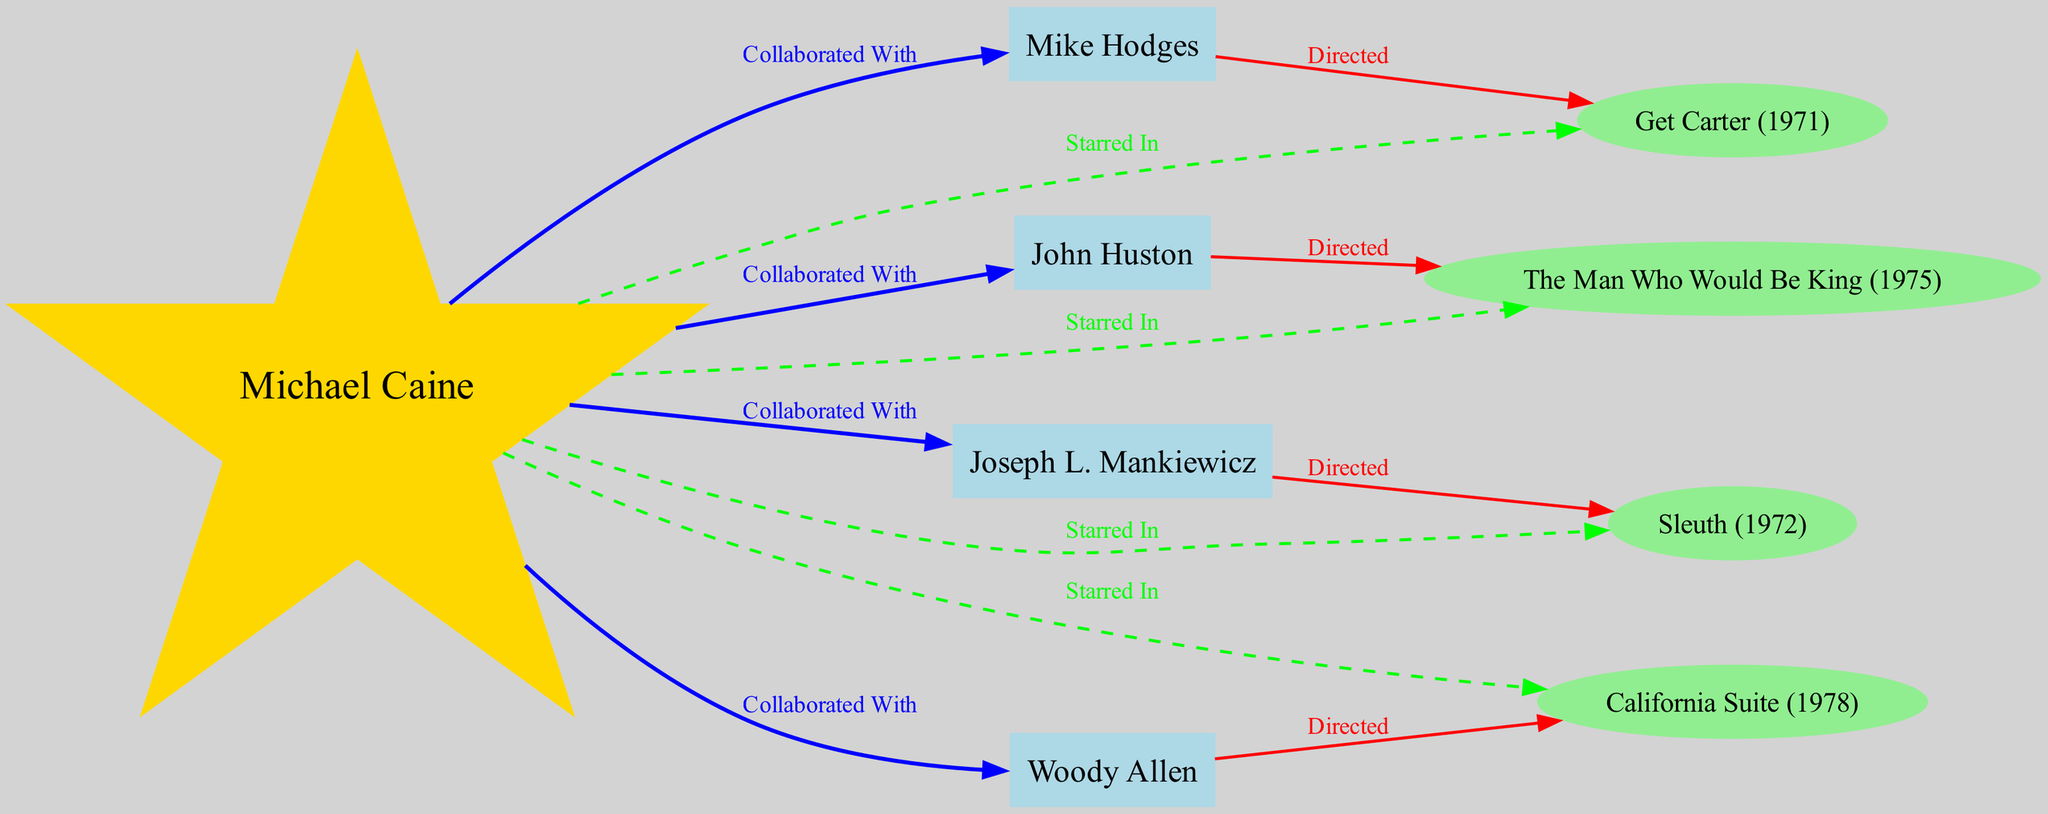What actor is at the center of the diagram? The diagram features Michael Caine as the central figure, represented as a star node. All connections and collaborations revolve around him, indicating his central role in the network of directors and films.
Answer: Michael Caine How many directors collaborated with Michael Caine? There are four directors listed as having collaborated with Michael Caine: John Huston, Mike Hodges, Joseph L. Mankiewicz, and Woody Allen. Each is connected to him with a blue edge labeled "Collaborated With."
Answer: Four Which film directed by Mike Hodges features Michael Caine? The diagram shows that Get Carter, directed by Mike Hodges, has a dashed green edge connecting it to Michael Caine, indicating he starred in that film.
Answer: Get Carter What color is used for the nodes representing directors? The directors are represented by light blue nodes in the diagram, distinguishing them from Michael Caine and the films in the network. This color choice helps viewers easily identify their roles as directors.
Answer: Light blue Which film did John Huston direct that features Michael Caine? The connection from John Huston to The Man Who Would Be King indicates that this film, directed by him, also stars Michael Caine, as shown by the dashed edge connecting Michael Caine to this film.
Answer: The Man Who Would Be King Which film collaborates with Woody Allen? California Suite is connected to Woody Allen, which is indicated by the directed edge that shows his role as the director of the film. Michael Caine starred in this film as well, illustrated by the dashed edge connecting him to it.
Answer: California Suite What is the relationship between Joseph L. Mankiewicz and Sleuth? Joseph L. Mankiewicz directed Sleuth, as represented by a red edge pointing from Joseph L. Mankiewicz to Sleuth, confirming his role as the film's director and showing its connection to Michael Caine who starred in it.
Answer: Directed How many films starred Michael Caine according to the diagram? The diagram indicates that Michael Caine starred in four films: Get Carter, Sleuth, The Man Who Would Be King, and California Suite. Each of these films is connected to him by dashed edges labeled "Starred In."
Answer: Four Which director is linked to the film Sleuth? Joseph L. Mankiewicz is linked to the film Sleuth as its director. This is shown by a directed edge from him to the film, establishing the directorship relationship in the diagram.
Answer: Joseph L. Mankiewicz 